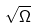Convert formula to latex. <formula><loc_0><loc_0><loc_500><loc_500>\sqrt { \Omega }</formula> 